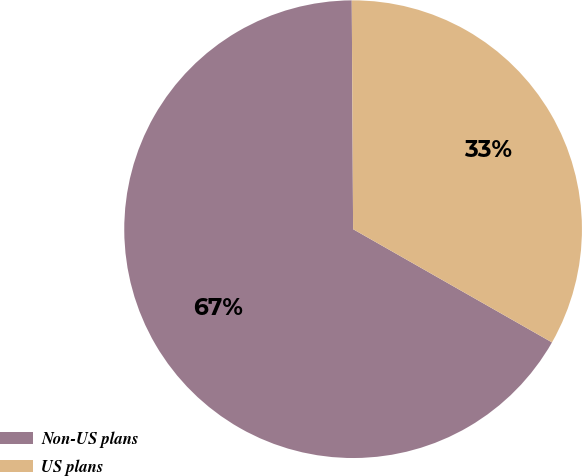Convert chart to OTSL. <chart><loc_0><loc_0><loc_500><loc_500><pie_chart><fcel>Non-US plans<fcel>US plans<nl><fcel>66.67%<fcel>33.33%<nl></chart> 